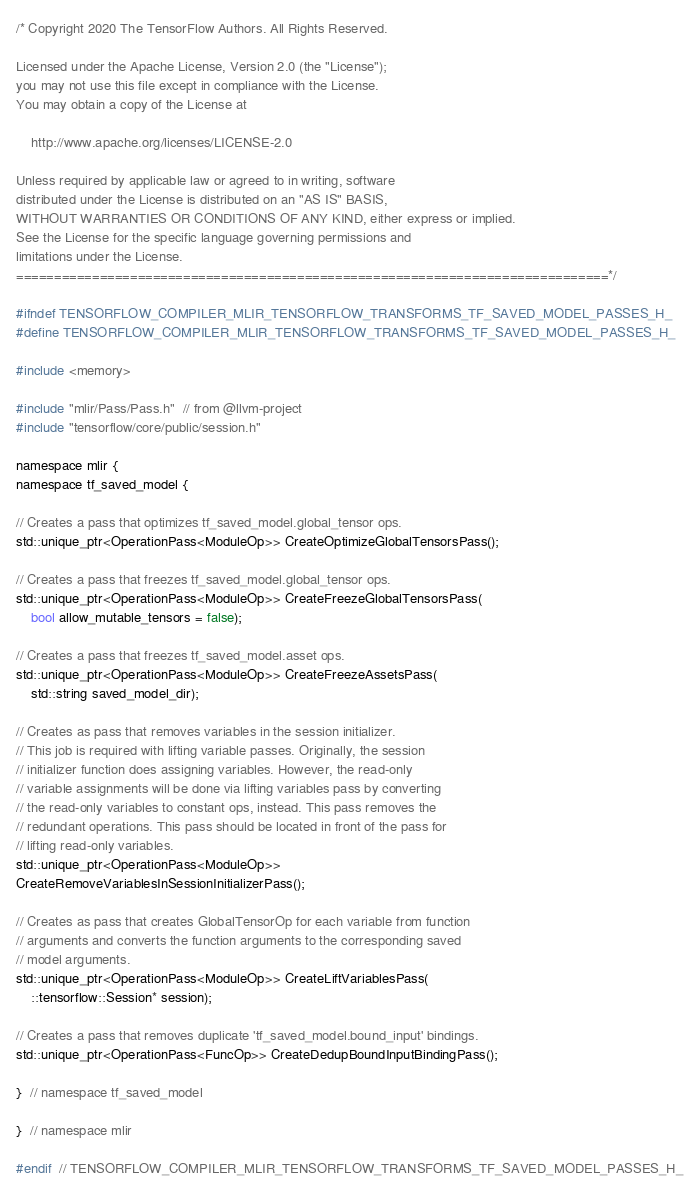<code> <loc_0><loc_0><loc_500><loc_500><_C_>/* Copyright 2020 The TensorFlow Authors. All Rights Reserved.

Licensed under the Apache License, Version 2.0 (the "License");
you may not use this file except in compliance with the License.
You may obtain a copy of the License at

    http://www.apache.org/licenses/LICENSE-2.0

Unless required by applicable law or agreed to in writing, software
distributed under the License is distributed on an "AS IS" BASIS,
WITHOUT WARRANTIES OR CONDITIONS OF ANY KIND, either express or implied.
See the License for the specific language governing permissions and
limitations under the License.
==============================================================================*/

#ifndef TENSORFLOW_COMPILER_MLIR_TENSORFLOW_TRANSFORMS_TF_SAVED_MODEL_PASSES_H_
#define TENSORFLOW_COMPILER_MLIR_TENSORFLOW_TRANSFORMS_TF_SAVED_MODEL_PASSES_H_

#include <memory>

#include "mlir/Pass/Pass.h"  // from @llvm-project
#include "tensorflow/core/public/session.h"

namespace mlir {
namespace tf_saved_model {

// Creates a pass that optimizes tf_saved_model.global_tensor ops.
std::unique_ptr<OperationPass<ModuleOp>> CreateOptimizeGlobalTensorsPass();

// Creates a pass that freezes tf_saved_model.global_tensor ops.
std::unique_ptr<OperationPass<ModuleOp>> CreateFreezeGlobalTensorsPass(
    bool allow_mutable_tensors = false);

// Creates a pass that freezes tf_saved_model.asset ops.
std::unique_ptr<OperationPass<ModuleOp>> CreateFreezeAssetsPass(
    std::string saved_model_dir);

// Creates as pass that removes variables in the session initializer.
// This job is required with lifting variable passes. Originally, the session
// initializer function does assigning variables. However, the read-only
// variable assignments will be done via lifting variables pass by converting
// the read-only variables to constant ops, instead. This pass removes the
// redundant operations. This pass should be located in front of the pass for
// lifting read-only variables.
std::unique_ptr<OperationPass<ModuleOp>>
CreateRemoveVariablesInSessionInitializerPass();

// Creates as pass that creates GlobalTensorOp for each variable from function
// arguments and converts the function arguments to the corresponding saved
// model arguments.
std::unique_ptr<OperationPass<ModuleOp>> CreateLiftVariablesPass(
    ::tensorflow::Session* session);

// Creates a pass that removes duplicate 'tf_saved_model.bound_input' bindings.
std::unique_ptr<OperationPass<FuncOp>> CreateDedupBoundInputBindingPass();

}  // namespace tf_saved_model

}  // namespace mlir

#endif  // TENSORFLOW_COMPILER_MLIR_TENSORFLOW_TRANSFORMS_TF_SAVED_MODEL_PASSES_H_
</code> 